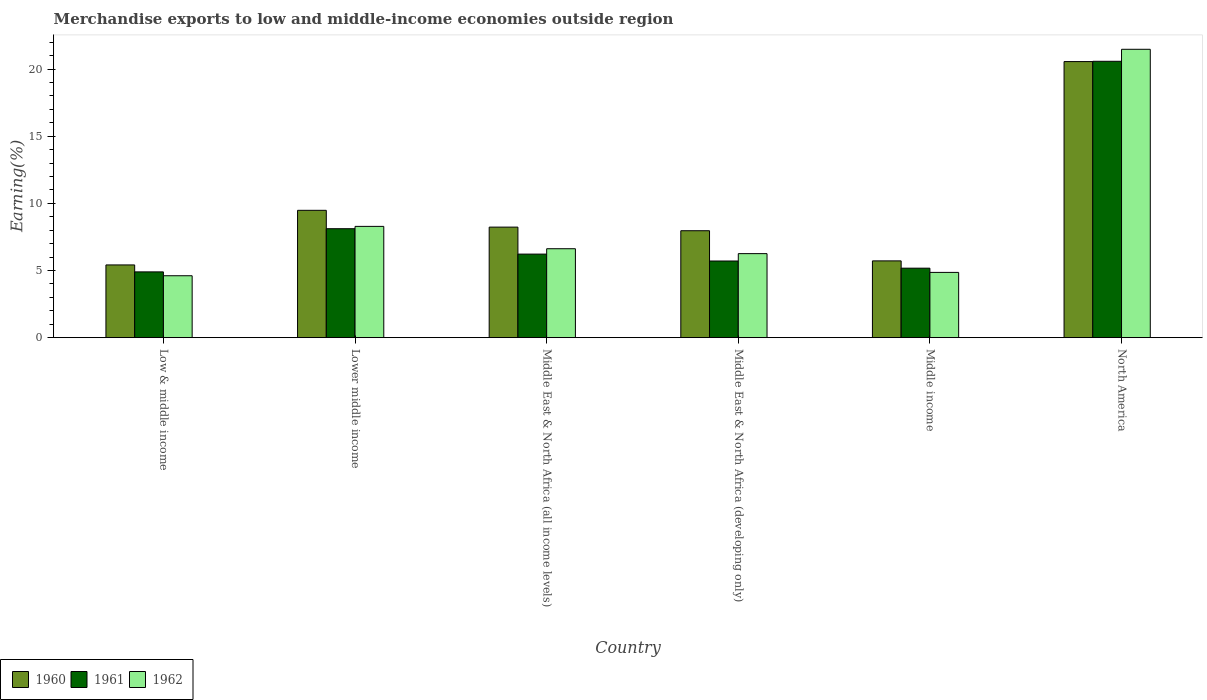How many groups of bars are there?
Keep it short and to the point. 6. Are the number of bars on each tick of the X-axis equal?
Offer a very short reply. Yes. In how many cases, is the number of bars for a given country not equal to the number of legend labels?
Make the answer very short. 0. What is the percentage of amount earned from merchandise exports in 1962 in Middle income?
Ensure brevity in your answer.  4.86. Across all countries, what is the maximum percentage of amount earned from merchandise exports in 1961?
Make the answer very short. 20.58. Across all countries, what is the minimum percentage of amount earned from merchandise exports in 1960?
Provide a short and direct response. 5.42. In which country was the percentage of amount earned from merchandise exports in 1961 maximum?
Ensure brevity in your answer.  North America. In which country was the percentage of amount earned from merchandise exports in 1961 minimum?
Keep it short and to the point. Low & middle income. What is the total percentage of amount earned from merchandise exports in 1960 in the graph?
Your answer should be compact. 57.37. What is the difference between the percentage of amount earned from merchandise exports in 1960 in Low & middle income and that in North America?
Your answer should be compact. -15.14. What is the difference between the percentage of amount earned from merchandise exports in 1962 in Middle income and the percentage of amount earned from merchandise exports in 1960 in North America?
Offer a terse response. -15.7. What is the average percentage of amount earned from merchandise exports in 1962 per country?
Make the answer very short. 8.69. What is the difference between the percentage of amount earned from merchandise exports of/in 1962 and percentage of amount earned from merchandise exports of/in 1960 in Low & middle income?
Provide a succinct answer. -0.81. In how many countries, is the percentage of amount earned from merchandise exports in 1962 greater than 2 %?
Your answer should be compact. 6. What is the ratio of the percentage of amount earned from merchandise exports in 1960 in Middle income to that in North America?
Provide a short and direct response. 0.28. Is the difference between the percentage of amount earned from merchandise exports in 1962 in Middle East & North Africa (developing only) and North America greater than the difference between the percentage of amount earned from merchandise exports in 1960 in Middle East & North Africa (developing only) and North America?
Your answer should be compact. No. What is the difference between the highest and the second highest percentage of amount earned from merchandise exports in 1960?
Your answer should be compact. -1.25. What is the difference between the highest and the lowest percentage of amount earned from merchandise exports in 1962?
Provide a short and direct response. 16.86. What does the 2nd bar from the right in Middle East & North Africa (all income levels) represents?
Keep it short and to the point. 1961. Is it the case that in every country, the sum of the percentage of amount earned from merchandise exports in 1962 and percentage of amount earned from merchandise exports in 1961 is greater than the percentage of amount earned from merchandise exports in 1960?
Provide a succinct answer. Yes. How many countries are there in the graph?
Offer a terse response. 6. What is the difference between two consecutive major ticks on the Y-axis?
Your response must be concise. 5. Are the values on the major ticks of Y-axis written in scientific E-notation?
Your response must be concise. No. Does the graph contain any zero values?
Your answer should be very brief. No. Where does the legend appear in the graph?
Provide a succinct answer. Bottom left. How many legend labels are there?
Give a very brief answer. 3. What is the title of the graph?
Provide a succinct answer. Merchandise exports to low and middle-income economies outside region. What is the label or title of the Y-axis?
Your answer should be compact. Earning(%). What is the Earning(%) in 1960 in Low & middle income?
Offer a very short reply. 5.42. What is the Earning(%) in 1961 in Low & middle income?
Your answer should be very brief. 4.9. What is the Earning(%) of 1962 in Low & middle income?
Your answer should be compact. 4.61. What is the Earning(%) of 1960 in Lower middle income?
Ensure brevity in your answer.  9.48. What is the Earning(%) in 1961 in Lower middle income?
Give a very brief answer. 8.11. What is the Earning(%) of 1962 in Lower middle income?
Offer a terse response. 8.29. What is the Earning(%) of 1960 in Middle East & North Africa (all income levels)?
Give a very brief answer. 8.23. What is the Earning(%) in 1961 in Middle East & North Africa (all income levels)?
Keep it short and to the point. 6.22. What is the Earning(%) of 1962 in Middle East & North Africa (all income levels)?
Keep it short and to the point. 6.62. What is the Earning(%) in 1960 in Middle East & North Africa (developing only)?
Keep it short and to the point. 7.96. What is the Earning(%) of 1961 in Middle East & North Africa (developing only)?
Ensure brevity in your answer.  5.71. What is the Earning(%) in 1962 in Middle East & North Africa (developing only)?
Give a very brief answer. 6.26. What is the Earning(%) of 1960 in Middle income?
Provide a succinct answer. 5.72. What is the Earning(%) in 1961 in Middle income?
Offer a very short reply. 5.17. What is the Earning(%) of 1962 in Middle income?
Provide a short and direct response. 4.86. What is the Earning(%) of 1960 in North America?
Offer a terse response. 20.56. What is the Earning(%) of 1961 in North America?
Make the answer very short. 20.58. What is the Earning(%) of 1962 in North America?
Offer a terse response. 21.47. Across all countries, what is the maximum Earning(%) in 1960?
Offer a very short reply. 20.56. Across all countries, what is the maximum Earning(%) in 1961?
Provide a succinct answer. 20.58. Across all countries, what is the maximum Earning(%) in 1962?
Offer a terse response. 21.47. Across all countries, what is the minimum Earning(%) of 1960?
Provide a succinct answer. 5.42. Across all countries, what is the minimum Earning(%) of 1961?
Provide a succinct answer. 4.9. Across all countries, what is the minimum Earning(%) of 1962?
Your answer should be compact. 4.61. What is the total Earning(%) of 1960 in the graph?
Give a very brief answer. 57.37. What is the total Earning(%) in 1961 in the graph?
Your response must be concise. 50.7. What is the total Earning(%) in 1962 in the graph?
Your response must be concise. 52.11. What is the difference between the Earning(%) of 1960 in Low & middle income and that in Lower middle income?
Make the answer very short. -4.07. What is the difference between the Earning(%) of 1961 in Low & middle income and that in Lower middle income?
Keep it short and to the point. -3.22. What is the difference between the Earning(%) in 1962 in Low & middle income and that in Lower middle income?
Provide a succinct answer. -3.68. What is the difference between the Earning(%) in 1960 in Low & middle income and that in Middle East & North Africa (all income levels)?
Ensure brevity in your answer.  -2.81. What is the difference between the Earning(%) of 1961 in Low & middle income and that in Middle East & North Africa (all income levels)?
Provide a succinct answer. -1.32. What is the difference between the Earning(%) of 1962 in Low & middle income and that in Middle East & North Africa (all income levels)?
Provide a short and direct response. -2.01. What is the difference between the Earning(%) in 1960 in Low & middle income and that in Middle East & North Africa (developing only)?
Offer a very short reply. -2.55. What is the difference between the Earning(%) in 1961 in Low & middle income and that in Middle East & North Africa (developing only)?
Keep it short and to the point. -0.81. What is the difference between the Earning(%) of 1962 in Low & middle income and that in Middle East & North Africa (developing only)?
Provide a short and direct response. -1.65. What is the difference between the Earning(%) in 1960 in Low & middle income and that in Middle income?
Provide a short and direct response. -0.3. What is the difference between the Earning(%) of 1961 in Low & middle income and that in Middle income?
Provide a succinct answer. -0.28. What is the difference between the Earning(%) in 1962 in Low & middle income and that in Middle income?
Your answer should be very brief. -0.25. What is the difference between the Earning(%) of 1960 in Low & middle income and that in North America?
Ensure brevity in your answer.  -15.14. What is the difference between the Earning(%) in 1961 in Low & middle income and that in North America?
Your answer should be very brief. -15.68. What is the difference between the Earning(%) in 1962 in Low & middle income and that in North America?
Offer a very short reply. -16.86. What is the difference between the Earning(%) of 1960 in Lower middle income and that in Middle East & North Africa (all income levels)?
Offer a terse response. 1.25. What is the difference between the Earning(%) in 1961 in Lower middle income and that in Middle East & North Africa (all income levels)?
Keep it short and to the point. 1.89. What is the difference between the Earning(%) of 1962 in Lower middle income and that in Middle East & North Africa (all income levels)?
Ensure brevity in your answer.  1.66. What is the difference between the Earning(%) in 1960 in Lower middle income and that in Middle East & North Africa (developing only)?
Ensure brevity in your answer.  1.52. What is the difference between the Earning(%) of 1961 in Lower middle income and that in Middle East & North Africa (developing only)?
Offer a very short reply. 2.41. What is the difference between the Earning(%) in 1962 in Lower middle income and that in Middle East & North Africa (developing only)?
Provide a short and direct response. 2.03. What is the difference between the Earning(%) in 1960 in Lower middle income and that in Middle income?
Your answer should be compact. 3.76. What is the difference between the Earning(%) in 1961 in Lower middle income and that in Middle income?
Provide a succinct answer. 2.94. What is the difference between the Earning(%) in 1962 in Lower middle income and that in Middle income?
Make the answer very short. 3.43. What is the difference between the Earning(%) of 1960 in Lower middle income and that in North America?
Give a very brief answer. -11.08. What is the difference between the Earning(%) in 1961 in Lower middle income and that in North America?
Give a very brief answer. -12.47. What is the difference between the Earning(%) in 1962 in Lower middle income and that in North America?
Offer a very short reply. -13.19. What is the difference between the Earning(%) in 1960 in Middle East & North Africa (all income levels) and that in Middle East & North Africa (developing only)?
Make the answer very short. 0.27. What is the difference between the Earning(%) in 1961 in Middle East & North Africa (all income levels) and that in Middle East & North Africa (developing only)?
Your answer should be very brief. 0.51. What is the difference between the Earning(%) of 1962 in Middle East & North Africa (all income levels) and that in Middle East & North Africa (developing only)?
Your response must be concise. 0.37. What is the difference between the Earning(%) of 1960 in Middle East & North Africa (all income levels) and that in Middle income?
Ensure brevity in your answer.  2.51. What is the difference between the Earning(%) in 1961 in Middle East & North Africa (all income levels) and that in Middle income?
Offer a very short reply. 1.05. What is the difference between the Earning(%) of 1962 in Middle East & North Africa (all income levels) and that in Middle income?
Make the answer very short. 1.76. What is the difference between the Earning(%) of 1960 in Middle East & North Africa (all income levels) and that in North America?
Offer a very short reply. -12.33. What is the difference between the Earning(%) in 1961 in Middle East & North Africa (all income levels) and that in North America?
Keep it short and to the point. -14.36. What is the difference between the Earning(%) of 1962 in Middle East & North Africa (all income levels) and that in North America?
Provide a short and direct response. -14.85. What is the difference between the Earning(%) of 1960 in Middle East & North Africa (developing only) and that in Middle income?
Your answer should be very brief. 2.25. What is the difference between the Earning(%) in 1961 in Middle East & North Africa (developing only) and that in Middle income?
Provide a short and direct response. 0.53. What is the difference between the Earning(%) of 1962 in Middle East & North Africa (developing only) and that in Middle income?
Keep it short and to the point. 1.4. What is the difference between the Earning(%) in 1960 in Middle East & North Africa (developing only) and that in North America?
Your answer should be compact. -12.59. What is the difference between the Earning(%) of 1961 in Middle East & North Africa (developing only) and that in North America?
Keep it short and to the point. -14.87. What is the difference between the Earning(%) in 1962 in Middle East & North Africa (developing only) and that in North America?
Ensure brevity in your answer.  -15.22. What is the difference between the Earning(%) of 1960 in Middle income and that in North America?
Your answer should be very brief. -14.84. What is the difference between the Earning(%) of 1961 in Middle income and that in North America?
Make the answer very short. -15.41. What is the difference between the Earning(%) in 1962 in Middle income and that in North America?
Provide a short and direct response. -16.61. What is the difference between the Earning(%) of 1960 in Low & middle income and the Earning(%) of 1961 in Lower middle income?
Keep it short and to the point. -2.7. What is the difference between the Earning(%) of 1960 in Low & middle income and the Earning(%) of 1962 in Lower middle income?
Give a very brief answer. -2.87. What is the difference between the Earning(%) of 1961 in Low & middle income and the Earning(%) of 1962 in Lower middle income?
Provide a short and direct response. -3.39. What is the difference between the Earning(%) in 1960 in Low & middle income and the Earning(%) in 1961 in Middle East & North Africa (all income levels)?
Your response must be concise. -0.81. What is the difference between the Earning(%) of 1960 in Low & middle income and the Earning(%) of 1962 in Middle East & North Africa (all income levels)?
Provide a short and direct response. -1.21. What is the difference between the Earning(%) of 1961 in Low & middle income and the Earning(%) of 1962 in Middle East & North Africa (all income levels)?
Give a very brief answer. -1.72. What is the difference between the Earning(%) of 1960 in Low & middle income and the Earning(%) of 1961 in Middle East & North Africa (developing only)?
Offer a very short reply. -0.29. What is the difference between the Earning(%) in 1960 in Low & middle income and the Earning(%) in 1962 in Middle East & North Africa (developing only)?
Offer a terse response. -0.84. What is the difference between the Earning(%) in 1961 in Low & middle income and the Earning(%) in 1962 in Middle East & North Africa (developing only)?
Provide a succinct answer. -1.36. What is the difference between the Earning(%) in 1960 in Low & middle income and the Earning(%) in 1961 in Middle income?
Give a very brief answer. 0.24. What is the difference between the Earning(%) of 1960 in Low & middle income and the Earning(%) of 1962 in Middle income?
Ensure brevity in your answer.  0.56. What is the difference between the Earning(%) in 1961 in Low & middle income and the Earning(%) in 1962 in Middle income?
Offer a terse response. 0.04. What is the difference between the Earning(%) of 1960 in Low & middle income and the Earning(%) of 1961 in North America?
Your answer should be very brief. -15.16. What is the difference between the Earning(%) of 1960 in Low & middle income and the Earning(%) of 1962 in North America?
Your answer should be very brief. -16.06. What is the difference between the Earning(%) in 1961 in Low & middle income and the Earning(%) in 1962 in North America?
Make the answer very short. -16.58. What is the difference between the Earning(%) of 1960 in Lower middle income and the Earning(%) of 1961 in Middle East & North Africa (all income levels)?
Ensure brevity in your answer.  3.26. What is the difference between the Earning(%) of 1960 in Lower middle income and the Earning(%) of 1962 in Middle East & North Africa (all income levels)?
Offer a very short reply. 2.86. What is the difference between the Earning(%) of 1961 in Lower middle income and the Earning(%) of 1962 in Middle East & North Africa (all income levels)?
Ensure brevity in your answer.  1.49. What is the difference between the Earning(%) in 1960 in Lower middle income and the Earning(%) in 1961 in Middle East & North Africa (developing only)?
Provide a succinct answer. 3.77. What is the difference between the Earning(%) of 1960 in Lower middle income and the Earning(%) of 1962 in Middle East & North Africa (developing only)?
Make the answer very short. 3.22. What is the difference between the Earning(%) of 1961 in Lower middle income and the Earning(%) of 1962 in Middle East & North Africa (developing only)?
Provide a short and direct response. 1.86. What is the difference between the Earning(%) in 1960 in Lower middle income and the Earning(%) in 1961 in Middle income?
Your answer should be compact. 4.31. What is the difference between the Earning(%) in 1960 in Lower middle income and the Earning(%) in 1962 in Middle income?
Make the answer very short. 4.62. What is the difference between the Earning(%) of 1961 in Lower middle income and the Earning(%) of 1962 in Middle income?
Your answer should be very brief. 3.25. What is the difference between the Earning(%) in 1960 in Lower middle income and the Earning(%) in 1961 in North America?
Provide a succinct answer. -11.1. What is the difference between the Earning(%) in 1960 in Lower middle income and the Earning(%) in 1962 in North America?
Ensure brevity in your answer.  -11.99. What is the difference between the Earning(%) in 1961 in Lower middle income and the Earning(%) in 1962 in North America?
Offer a terse response. -13.36. What is the difference between the Earning(%) in 1960 in Middle East & North Africa (all income levels) and the Earning(%) in 1961 in Middle East & North Africa (developing only)?
Ensure brevity in your answer.  2.52. What is the difference between the Earning(%) of 1960 in Middle East & North Africa (all income levels) and the Earning(%) of 1962 in Middle East & North Africa (developing only)?
Offer a terse response. 1.97. What is the difference between the Earning(%) in 1961 in Middle East & North Africa (all income levels) and the Earning(%) in 1962 in Middle East & North Africa (developing only)?
Offer a terse response. -0.04. What is the difference between the Earning(%) of 1960 in Middle East & North Africa (all income levels) and the Earning(%) of 1961 in Middle income?
Your response must be concise. 3.06. What is the difference between the Earning(%) in 1960 in Middle East & North Africa (all income levels) and the Earning(%) in 1962 in Middle income?
Your response must be concise. 3.37. What is the difference between the Earning(%) in 1961 in Middle East & North Africa (all income levels) and the Earning(%) in 1962 in Middle income?
Give a very brief answer. 1.36. What is the difference between the Earning(%) of 1960 in Middle East & North Africa (all income levels) and the Earning(%) of 1961 in North America?
Your answer should be very brief. -12.35. What is the difference between the Earning(%) of 1960 in Middle East & North Africa (all income levels) and the Earning(%) of 1962 in North America?
Ensure brevity in your answer.  -13.24. What is the difference between the Earning(%) of 1961 in Middle East & North Africa (all income levels) and the Earning(%) of 1962 in North America?
Offer a very short reply. -15.25. What is the difference between the Earning(%) in 1960 in Middle East & North Africa (developing only) and the Earning(%) in 1961 in Middle income?
Your answer should be very brief. 2.79. What is the difference between the Earning(%) in 1960 in Middle East & North Africa (developing only) and the Earning(%) in 1962 in Middle income?
Your answer should be compact. 3.1. What is the difference between the Earning(%) of 1961 in Middle East & North Africa (developing only) and the Earning(%) of 1962 in Middle income?
Keep it short and to the point. 0.85. What is the difference between the Earning(%) of 1960 in Middle East & North Africa (developing only) and the Earning(%) of 1961 in North America?
Your response must be concise. -12.62. What is the difference between the Earning(%) of 1960 in Middle East & North Africa (developing only) and the Earning(%) of 1962 in North America?
Offer a terse response. -13.51. What is the difference between the Earning(%) in 1961 in Middle East & North Africa (developing only) and the Earning(%) in 1962 in North America?
Offer a very short reply. -15.77. What is the difference between the Earning(%) in 1960 in Middle income and the Earning(%) in 1961 in North America?
Provide a short and direct response. -14.86. What is the difference between the Earning(%) in 1960 in Middle income and the Earning(%) in 1962 in North America?
Offer a very short reply. -15.76. What is the difference between the Earning(%) of 1961 in Middle income and the Earning(%) of 1962 in North America?
Your answer should be very brief. -16.3. What is the average Earning(%) in 1960 per country?
Your answer should be very brief. 9.56. What is the average Earning(%) in 1961 per country?
Provide a short and direct response. 8.45. What is the average Earning(%) of 1962 per country?
Provide a short and direct response. 8.69. What is the difference between the Earning(%) in 1960 and Earning(%) in 1961 in Low & middle income?
Provide a succinct answer. 0.52. What is the difference between the Earning(%) in 1960 and Earning(%) in 1962 in Low & middle income?
Offer a terse response. 0.81. What is the difference between the Earning(%) in 1961 and Earning(%) in 1962 in Low & middle income?
Provide a short and direct response. 0.29. What is the difference between the Earning(%) in 1960 and Earning(%) in 1961 in Lower middle income?
Provide a short and direct response. 1.37. What is the difference between the Earning(%) in 1960 and Earning(%) in 1962 in Lower middle income?
Provide a short and direct response. 1.2. What is the difference between the Earning(%) of 1961 and Earning(%) of 1962 in Lower middle income?
Your answer should be compact. -0.17. What is the difference between the Earning(%) in 1960 and Earning(%) in 1961 in Middle East & North Africa (all income levels)?
Your answer should be very brief. 2.01. What is the difference between the Earning(%) of 1960 and Earning(%) of 1962 in Middle East & North Africa (all income levels)?
Provide a short and direct response. 1.61. What is the difference between the Earning(%) in 1961 and Earning(%) in 1962 in Middle East & North Africa (all income levels)?
Provide a short and direct response. -0.4. What is the difference between the Earning(%) in 1960 and Earning(%) in 1961 in Middle East & North Africa (developing only)?
Your answer should be very brief. 2.26. What is the difference between the Earning(%) of 1960 and Earning(%) of 1962 in Middle East & North Africa (developing only)?
Offer a very short reply. 1.71. What is the difference between the Earning(%) in 1961 and Earning(%) in 1962 in Middle East & North Africa (developing only)?
Provide a short and direct response. -0.55. What is the difference between the Earning(%) in 1960 and Earning(%) in 1961 in Middle income?
Provide a short and direct response. 0.54. What is the difference between the Earning(%) of 1960 and Earning(%) of 1962 in Middle income?
Offer a very short reply. 0.86. What is the difference between the Earning(%) in 1961 and Earning(%) in 1962 in Middle income?
Your answer should be very brief. 0.31. What is the difference between the Earning(%) in 1960 and Earning(%) in 1961 in North America?
Offer a terse response. -0.02. What is the difference between the Earning(%) in 1960 and Earning(%) in 1962 in North America?
Your response must be concise. -0.92. What is the difference between the Earning(%) of 1961 and Earning(%) of 1962 in North America?
Provide a short and direct response. -0.89. What is the ratio of the Earning(%) in 1960 in Low & middle income to that in Lower middle income?
Your answer should be compact. 0.57. What is the ratio of the Earning(%) of 1961 in Low & middle income to that in Lower middle income?
Offer a very short reply. 0.6. What is the ratio of the Earning(%) of 1962 in Low & middle income to that in Lower middle income?
Provide a succinct answer. 0.56. What is the ratio of the Earning(%) of 1960 in Low & middle income to that in Middle East & North Africa (all income levels)?
Your answer should be very brief. 0.66. What is the ratio of the Earning(%) in 1961 in Low & middle income to that in Middle East & North Africa (all income levels)?
Keep it short and to the point. 0.79. What is the ratio of the Earning(%) in 1962 in Low & middle income to that in Middle East & North Africa (all income levels)?
Offer a very short reply. 0.7. What is the ratio of the Earning(%) in 1960 in Low & middle income to that in Middle East & North Africa (developing only)?
Ensure brevity in your answer.  0.68. What is the ratio of the Earning(%) in 1961 in Low & middle income to that in Middle East & North Africa (developing only)?
Ensure brevity in your answer.  0.86. What is the ratio of the Earning(%) of 1962 in Low & middle income to that in Middle East & North Africa (developing only)?
Your answer should be compact. 0.74. What is the ratio of the Earning(%) of 1961 in Low & middle income to that in Middle income?
Provide a succinct answer. 0.95. What is the ratio of the Earning(%) in 1962 in Low & middle income to that in Middle income?
Give a very brief answer. 0.95. What is the ratio of the Earning(%) in 1960 in Low & middle income to that in North America?
Provide a succinct answer. 0.26. What is the ratio of the Earning(%) of 1961 in Low & middle income to that in North America?
Give a very brief answer. 0.24. What is the ratio of the Earning(%) in 1962 in Low & middle income to that in North America?
Your answer should be compact. 0.21. What is the ratio of the Earning(%) of 1960 in Lower middle income to that in Middle East & North Africa (all income levels)?
Your answer should be very brief. 1.15. What is the ratio of the Earning(%) in 1961 in Lower middle income to that in Middle East & North Africa (all income levels)?
Give a very brief answer. 1.3. What is the ratio of the Earning(%) of 1962 in Lower middle income to that in Middle East & North Africa (all income levels)?
Your answer should be very brief. 1.25. What is the ratio of the Earning(%) of 1960 in Lower middle income to that in Middle East & North Africa (developing only)?
Give a very brief answer. 1.19. What is the ratio of the Earning(%) in 1961 in Lower middle income to that in Middle East & North Africa (developing only)?
Ensure brevity in your answer.  1.42. What is the ratio of the Earning(%) in 1962 in Lower middle income to that in Middle East & North Africa (developing only)?
Offer a terse response. 1.32. What is the ratio of the Earning(%) in 1960 in Lower middle income to that in Middle income?
Your response must be concise. 1.66. What is the ratio of the Earning(%) in 1961 in Lower middle income to that in Middle income?
Provide a succinct answer. 1.57. What is the ratio of the Earning(%) in 1962 in Lower middle income to that in Middle income?
Offer a very short reply. 1.71. What is the ratio of the Earning(%) of 1960 in Lower middle income to that in North America?
Give a very brief answer. 0.46. What is the ratio of the Earning(%) in 1961 in Lower middle income to that in North America?
Give a very brief answer. 0.39. What is the ratio of the Earning(%) of 1962 in Lower middle income to that in North America?
Provide a short and direct response. 0.39. What is the ratio of the Earning(%) in 1960 in Middle East & North Africa (all income levels) to that in Middle East & North Africa (developing only)?
Offer a terse response. 1.03. What is the ratio of the Earning(%) in 1961 in Middle East & North Africa (all income levels) to that in Middle East & North Africa (developing only)?
Offer a terse response. 1.09. What is the ratio of the Earning(%) of 1962 in Middle East & North Africa (all income levels) to that in Middle East & North Africa (developing only)?
Your response must be concise. 1.06. What is the ratio of the Earning(%) of 1960 in Middle East & North Africa (all income levels) to that in Middle income?
Keep it short and to the point. 1.44. What is the ratio of the Earning(%) in 1961 in Middle East & North Africa (all income levels) to that in Middle income?
Provide a succinct answer. 1.2. What is the ratio of the Earning(%) of 1962 in Middle East & North Africa (all income levels) to that in Middle income?
Give a very brief answer. 1.36. What is the ratio of the Earning(%) in 1960 in Middle East & North Africa (all income levels) to that in North America?
Offer a terse response. 0.4. What is the ratio of the Earning(%) of 1961 in Middle East & North Africa (all income levels) to that in North America?
Keep it short and to the point. 0.3. What is the ratio of the Earning(%) in 1962 in Middle East & North Africa (all income levels) to that in North America?
Keep it short and to the point. 0.31. What is the ratio of the Earning(%) in 1960 in Middle East & North Africa (developing only) to that in Middle income?
Your response must be concise. 1.39. What is the ratio of the Earning(%) in 1961 in Middle East & North Africa (developing only) to that in Middle income?
Provide a succinct answer. 1.1. What is the ratio of the Earning(%) of 1962 in Middle East & North Africa (developing only) to that in Middle income?
Provide a short and direct response. 1.29. What is the ratio of the Earning(%) of 1960 in Middle East & North Africa (developing only) to that in North America?
Provide a succinct answer. 0.39. What is the ratio of the Earning(%) in 1961 in Middle East & North Africa (developing only) to that in North America?
Offer a very short reply. 0.28. What is the ratio of the Earning(%) in 1962 in Middle East & North Africa (developing only) to that in North America?
Your answer should be compact. 0.29. What is the ratio of the Earning(%) of 1960 in Middle income to that in North America?
Keep it short and to the point. 0.28. What is the ratio of the Earning(%) of 1961 in Middle income to that in North America?
Ensure brevity in your answer.  0.25. What is the ratio of the Earning(%) of 1962 in Middle income to that in North America?
Ensure brevity in your answer.  0.23. What is the difference between the highest and the second highest Earning(%) of 1960?
Your answer should be very brief. 11.08. What is the difference between the highest and the second highest Earning(%) of 1961?
Offer a very short reply. 12.47. What is the difference between the highest and the second highest Earning(%) of 1962?
Keep it short and to the point. 13.19. What is the difference between the highest and the lowest Earning(%) of 1960?
Ensure brevity in your answer.  15.14. What is the difference between the highest and the lowest Earning(%) of 1961?
Offer a very short reply. 15.68. What is the difference between the highest and the lowest Earning(%) in 1962?
Provide a succinct answer. 16.86. 